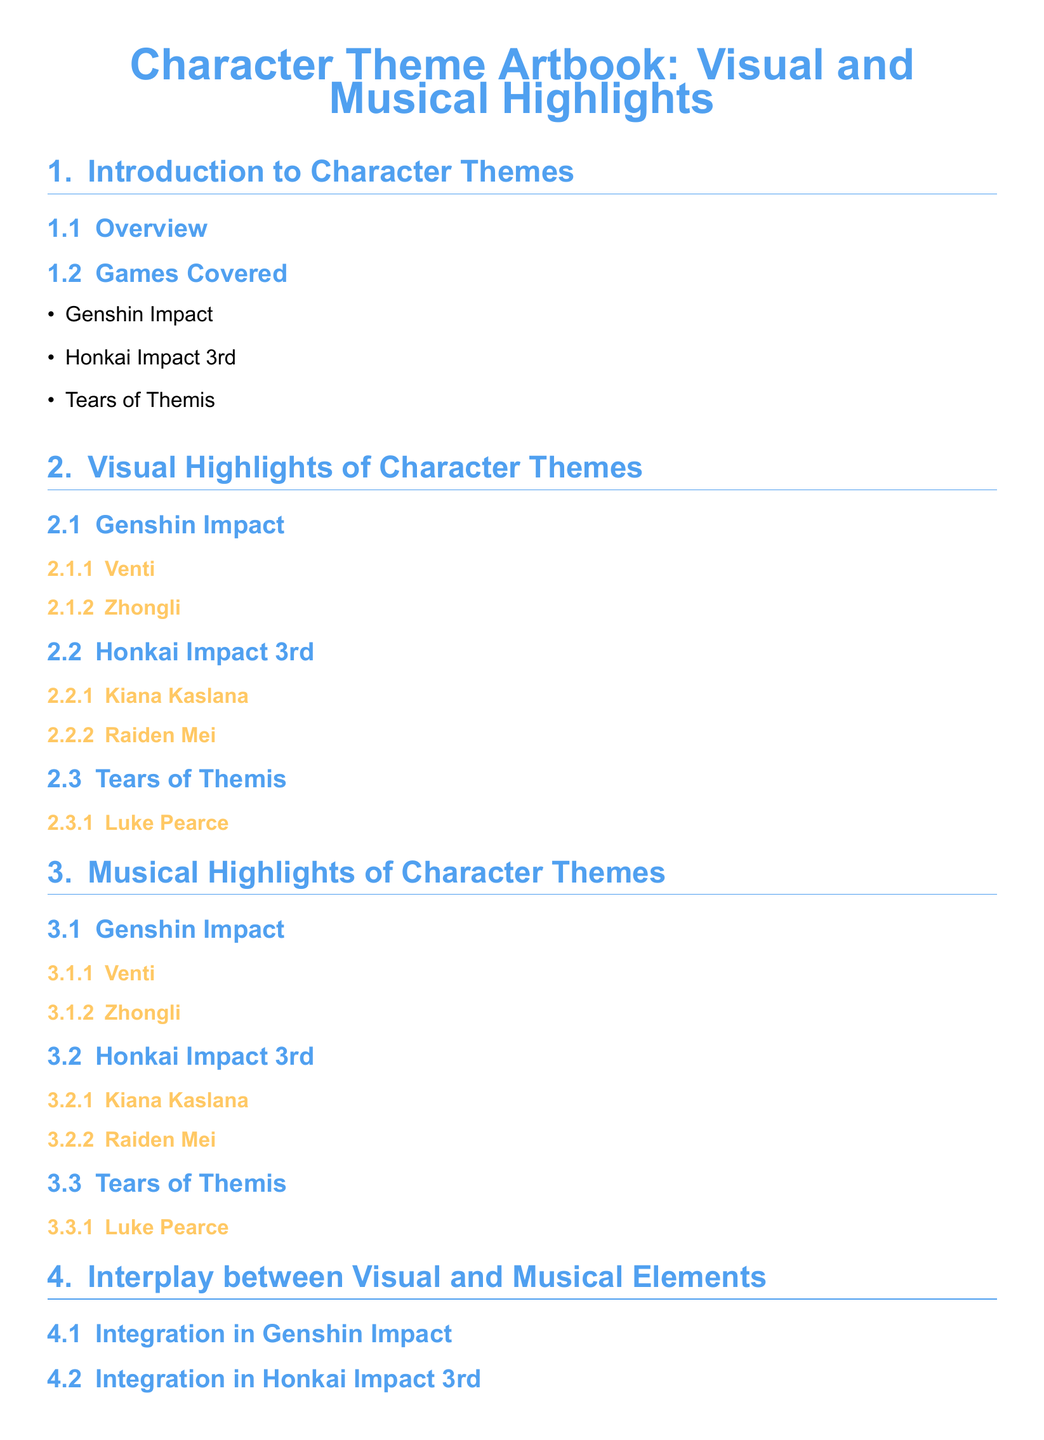What games are covered in the artbook? The document lists the games analyzed in the artbook, specifically Genshin Impact, Honkai Impact 3rd, and Tears of Themis.
Answer: Genshin Impact, Honkai Impact 3rd, Tears of Themis Who is the character highlighted from Genshin Impact? The section provides examples of characters from Genshin Impact, which include Venti and Zhongli.
Answer: Venti, Zhongli Which character from Honkai Impact 3rd is mentioned? The document highlights specific characters from Honkai Impact 3rd, including Kiana Kaslana and Raiden Mei.
Answer: Kiana Kaslana, Raiden Mei What is the focus of the 'Interplay between Visual and Musical Elements' section? This section explores the integration of visual and musical elements in the three games mentioned in the document.
Answer: Integration How many characters from Tears of Themis are included? The document includes one character from Tears of Themis which is Luke Pearce.
Answer: One What significance is mentioned in the conclusion? The conclusion addresses the overall significance of creating a multi-sensory experience within the games.
Answer: Multi-Sensory Experience Which section discusses musical highlights? The section titled 'Musical Highlights of Character Themes' discusses the musical elements related to each character.
Answer: Musical Highlights of Character Themes How many sections are there in total? The document is organized into six main sections, including the introduction and conclusion.
Answer: Six 